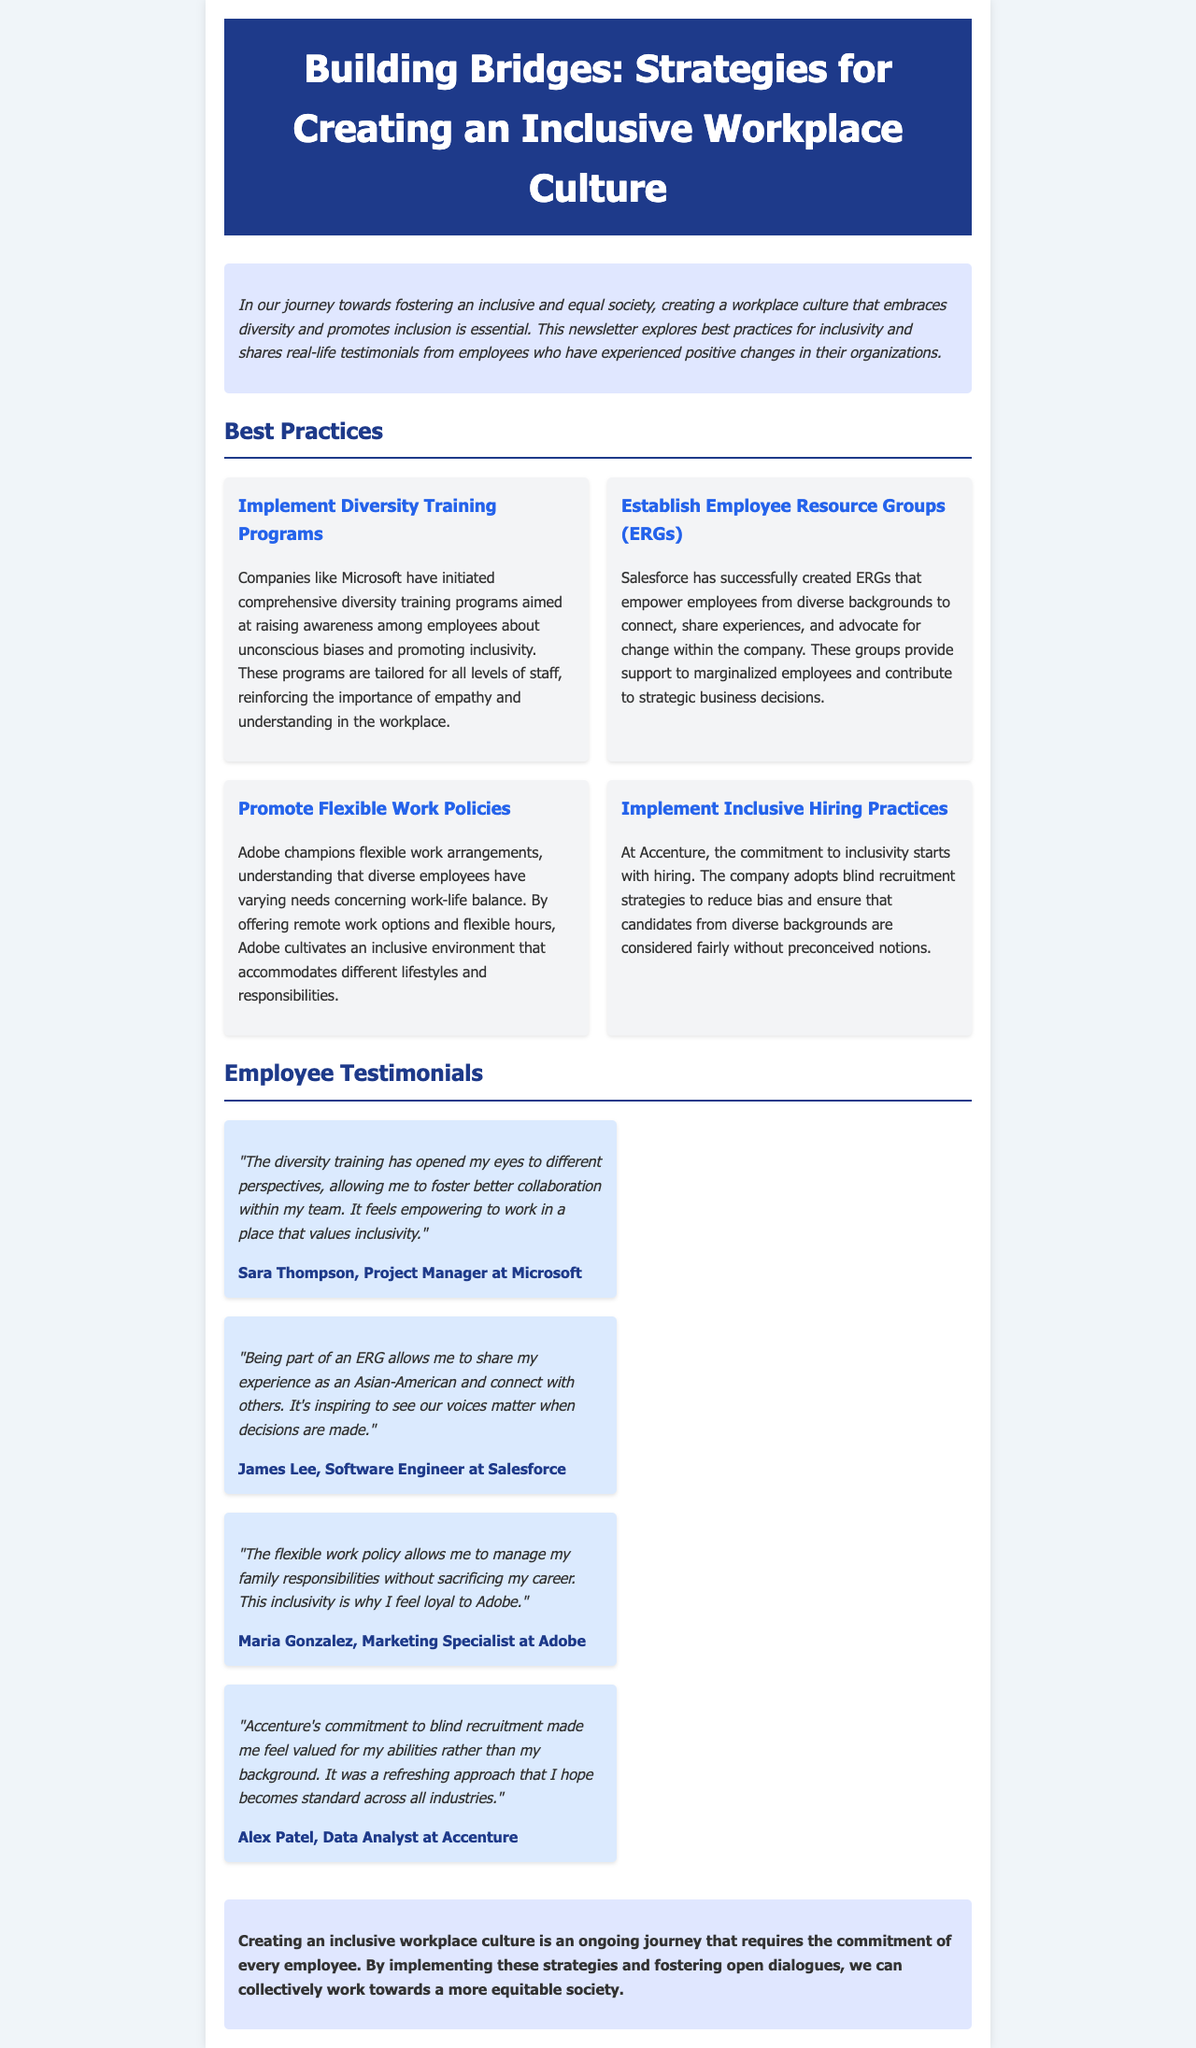What is the title of the newsletter? The title of the newsletter is displayed prominently at the top, which is "Building Bridges: Strategies for Creating an Inclusive Workplace Culture."
Answer: Building Bridges: Strategies for Creating an Inclusive Workplace Culture Which company initiated comprehensive diversity training programs? The document states that Microsoft has initiated comprehensive diversity training programs aimed at raising awareness.
Answer: Microsoft What benefit does Adobe's flexible work policy provide? The flexible work policy at Adobe allows employees to manage family responsibilities without sacrificing their career.
Answer: Work-life balance How many testimonials are shared in the document? The document includes four employee testimonials highlighting their experiences regarding workplace inclusivity.
Answer: Four Who is the author of the testimonial regarding blind recruitment? The testimonial regarding blind recruitment is given by Alex Patel, a Data Analyst at Accenture.
Answer: Alex Patel What is one of the practices Salesforce implemented to promote inclusivity? Salesforce established Employee Resource Groups (ERGs) to empower employees from diverse backgrounds to connect and advocate for change.
Answer: Employee Resource Groups What is emphasized as an ongoing journey in the closing note? The closing note emphasizes that creating an inclusive workplace culture is an ongoing journey requiring the commitment of every employee.
Answer: Commitment Which company provides support to marginalized employees through ERGs? The document mentions that Salesforce provides support to marginalized employees through ERGs.
Answer: Salesforce What color is used for the header background? The header background color in the newsletter is a shade of blue denoted by the hex code #1e3a8a.
Answer: Blue 